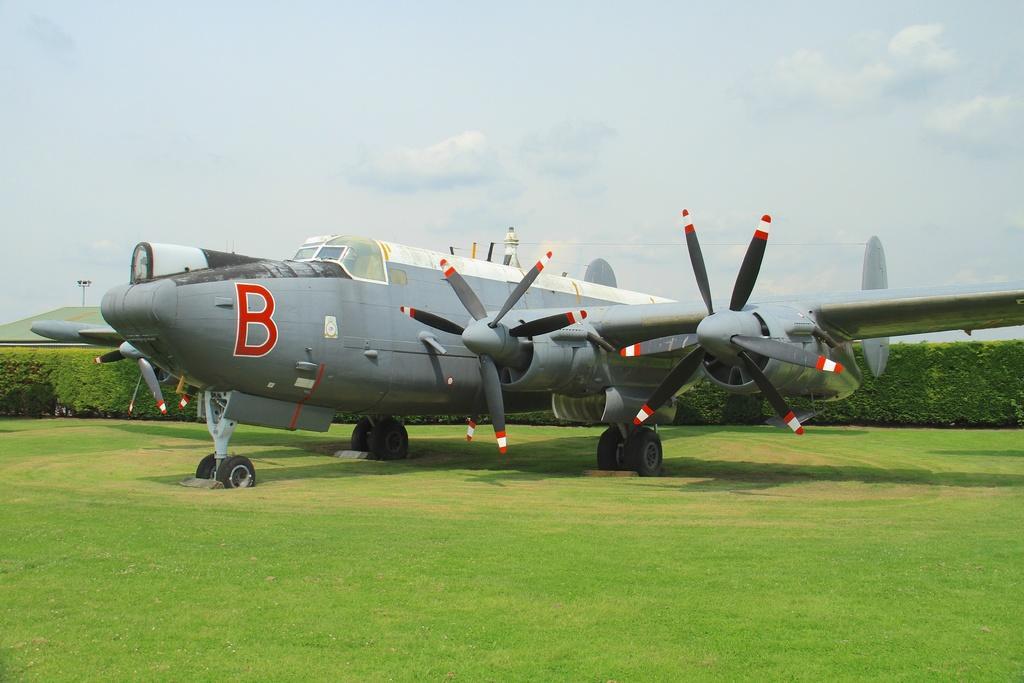How would you summarize this image in a sentence or two? In the center of the image there is an aeroplane. In the background we can see a hedge and a pole. At the top there is sky. 